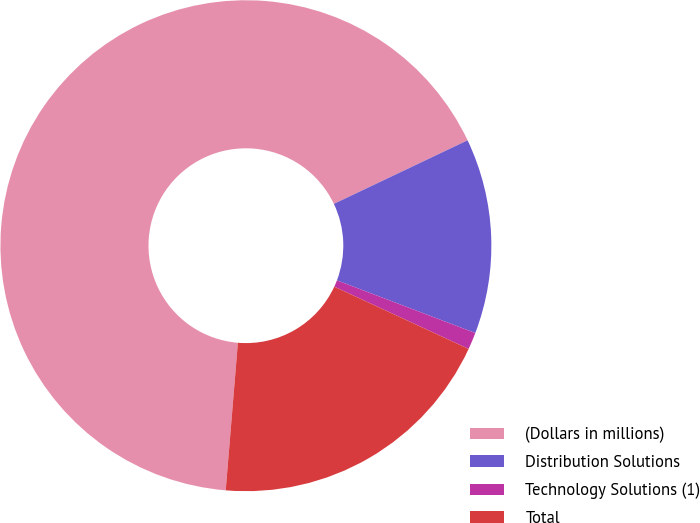Convert chart. <chart><loc_0><loc_0><loc_500><loc_500><pie_chart><fcel>(Dollars in millions)<fcel>Distribution Solutions<fcel>Technology Solutions (1)<fcel>Total<nl><fcel>66.62%<fcel>12.85%<fcel>1.12%<fcel>19.4%<nl></chart> 